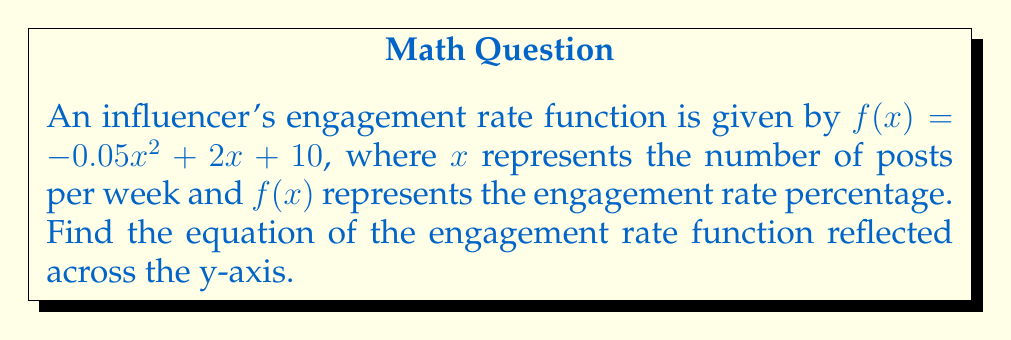What is the answer to this math problem? To reflect a function across the y-axis, we replace every $x$ with $-x$ in the original function. This is because the y-axis has the equation $x = 0$, and reflecting across it changes the sign of all x-coordinates.

Step 1: Start with the original function
$f(x) = -0.05x^2 + 2x + 10$

Step 2: Replace every $x$ with $-x$
$f(-x) = -0.05(-x)^2 + 2(-x) + 10$

Step 3: Simplify
$f(-x) = -0.05x^2 - 2x + 10$

The resulting function $f(-x) = -0.05x^2 - 2x + 10$ represents the reflection of the original engagement rate function across the y-axis.
Answer: $f(-x) = -0.05x^2 - 2x + 10$ 